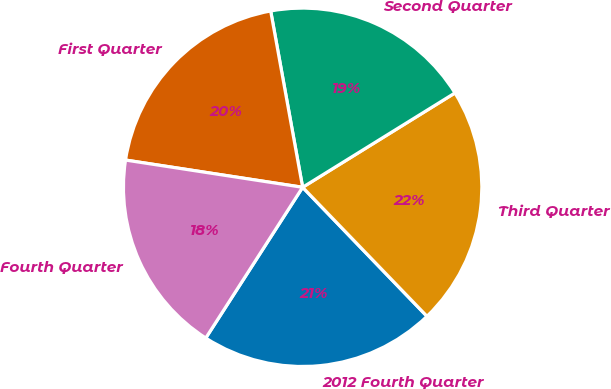Convert chart. <chart><loc_0><loc_0><loc_500><loc_500><pie_chart><fcel>2012 Fourth Quarter<fcel>Third Quarter<fcel>Second Quarter<fcel>First Quarter<fcel>Fourth Quarter<nl><fcel>21.3%<fcel>21.62%<fcel>19.03%<fcel>19.72%<fcel>18.34%<nl></chart> 